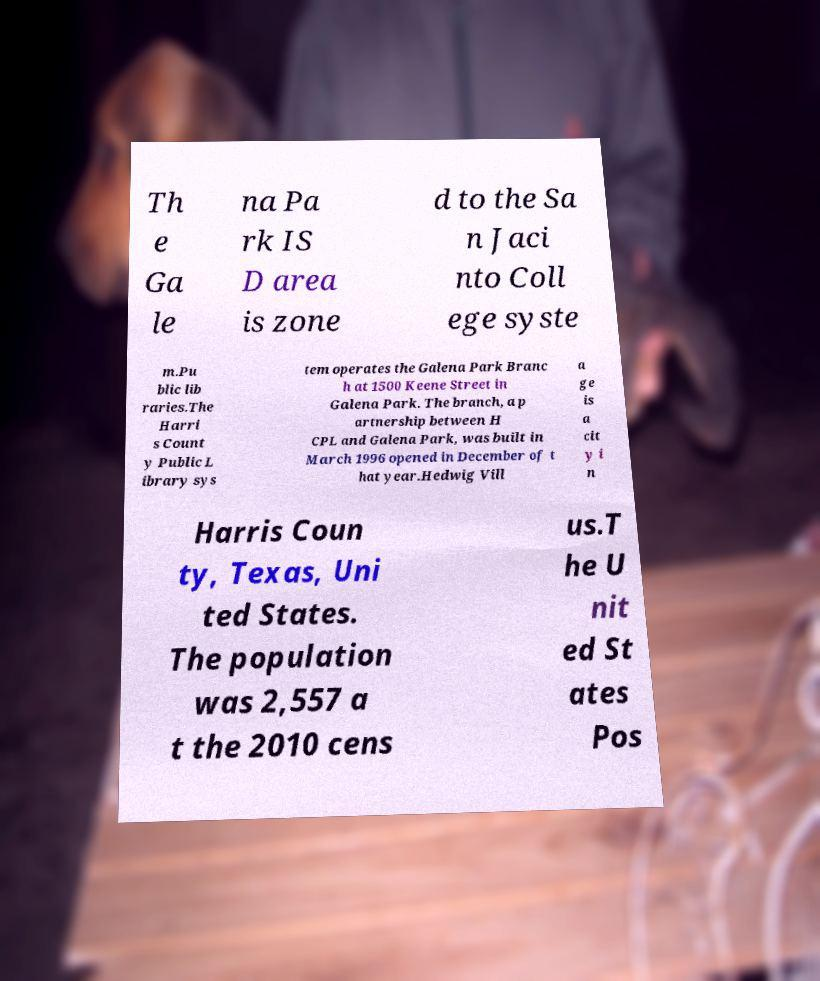I need the written content from this picture converted into text. Can you do that? Th e Ga le na Pa rk IS D area is zone d to the Sa n Jaci nto Coll ege syste m.Pu blic lib raries.The Harri s Count y Public L ibrary sys tem operates the Galena Park Branc h at 1500 Keene Street in Galena Park. The branch, a p artnership between H CPL and Galena Park, was built in March 1996 opened in December of t hat year.Hedwig Vill a ge is a cit y i n Harris Coun ty, Texas, Uni ted States. The population was 2,557 a t the 2010 cens us.T he U nit ed St ates Pos 